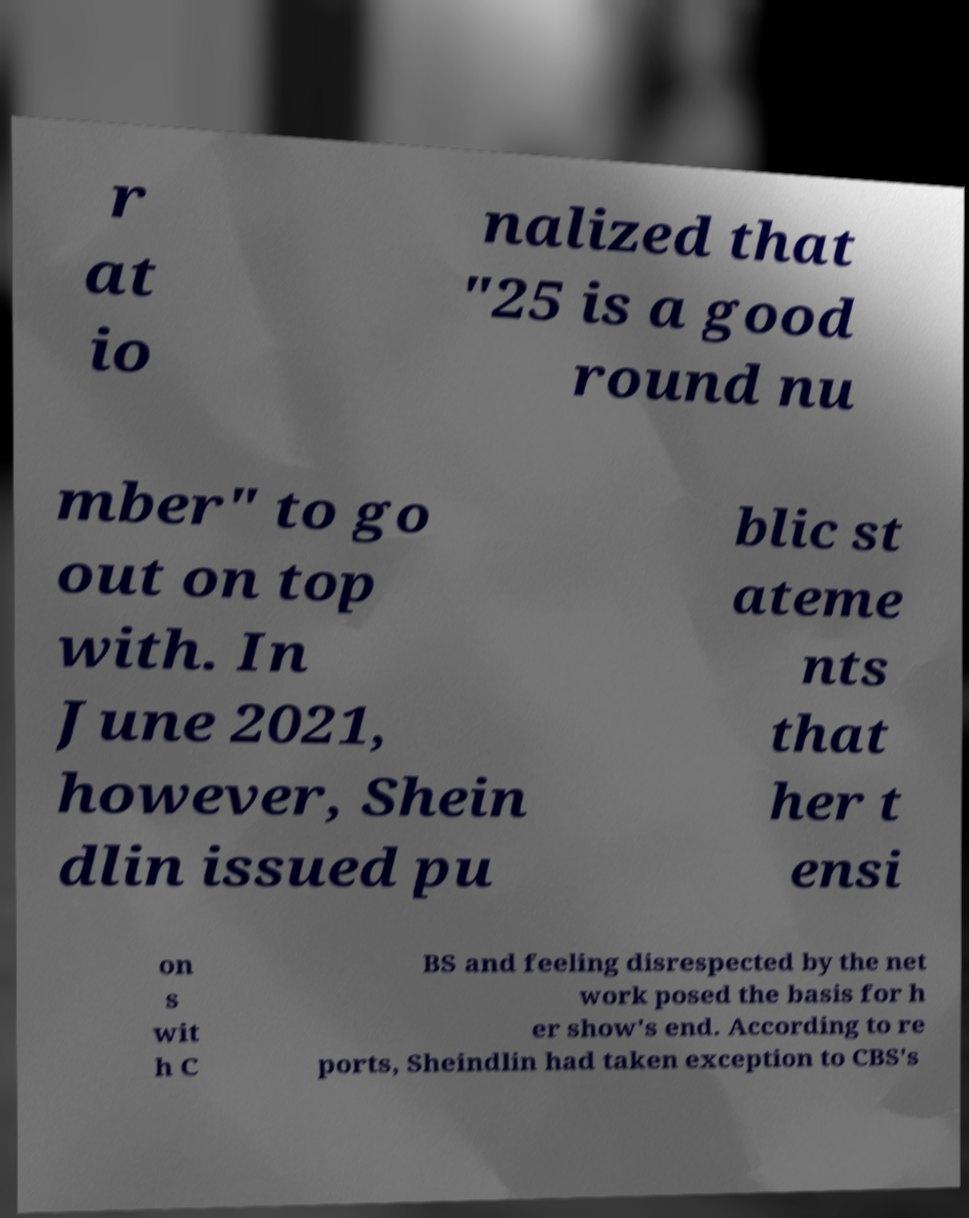Could you extract and type out the text from this image? r at io nalized that "25 is a good round nu mber" to go out on top with. In June 2021, however, Shein dlin issued pu blic st ateme nts that her t ensi on s wit h C BS and feeling disrespected by the net work posed the basis for h er show's end. According to re ports, Sheindlin had taken exception to CBS's 